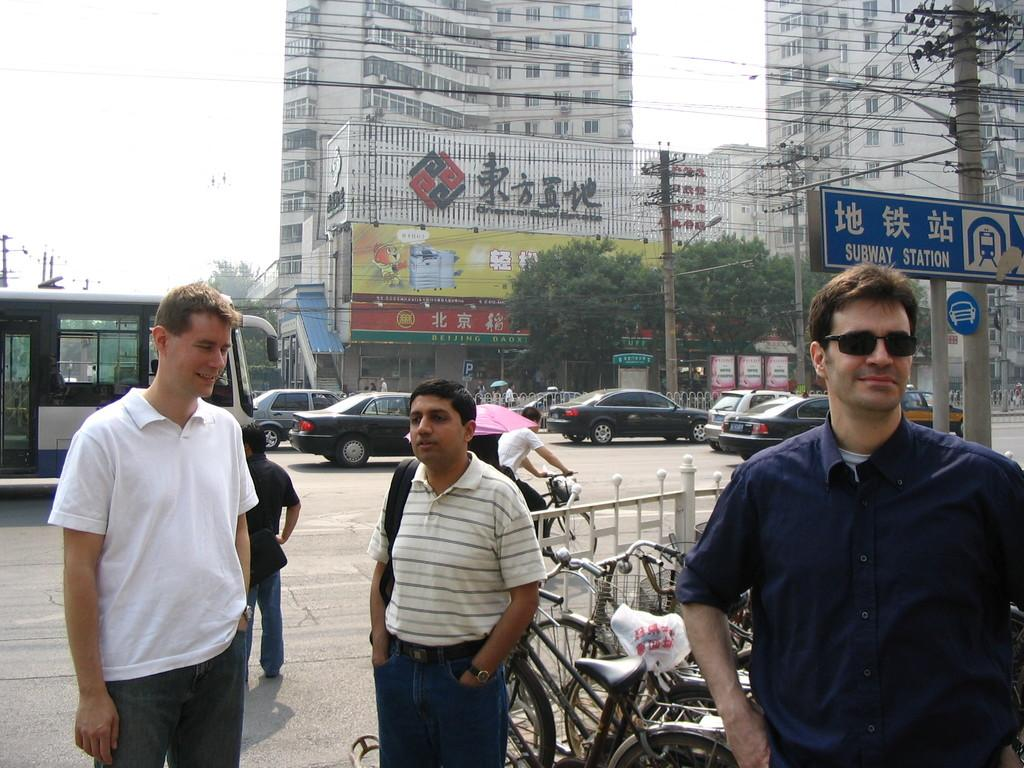What are the people in the image doing? The group of people is standing on the road. What else can be seen in the image besides the people? There are vehicles and buildings visible in the image. What type of creature can be seen climbing the arch in the image? There is no arch or creature present in the image. 